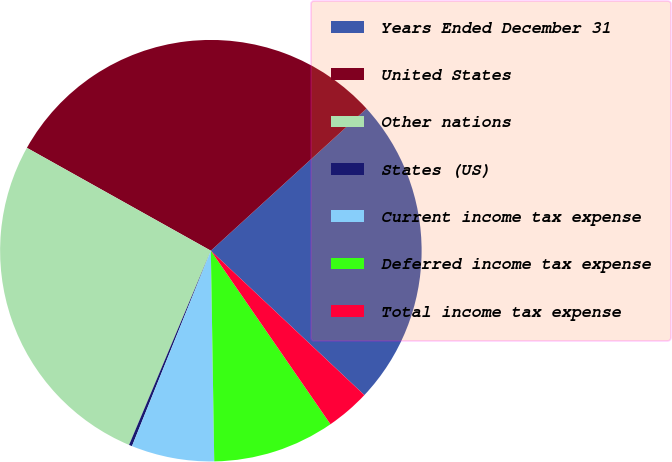Convert chart. <chart><loc_0><loc_0><loc_500><loc_500><pie_chart><fcel>Years Ended December 31<fcel>United States<fcel>Other nations<fcel>States (US)<fcel>Current income tax expense<fcel>Deferred income tax expense<fcel>Total income tax expense<nl><fcel>23.79%<fcel>30.11%<fcel>26.77%<fcel>0.24%<fcel>6.36%<fcel>9.35%<fcel>3.38%<nl></chart> 